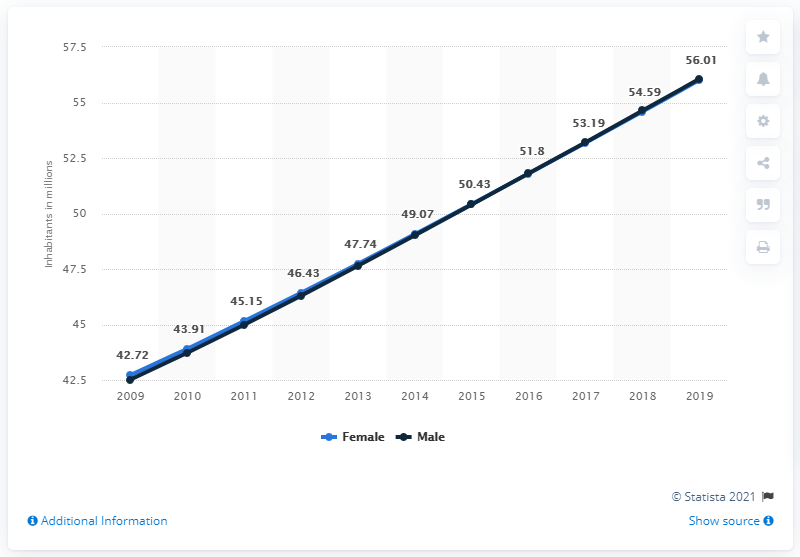Specify some key components in this picture. The highest value on the chart was 56.01. The male population of Ethiopia in 2019 was approximately 56.01 million. The highest population and the lowest population are 13.29 apart. 